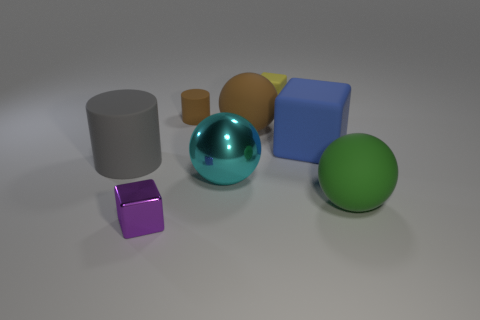Do the matte thing that is in front of the large metallic thing and the small rubber cube have the same color? No, they do not have the same color. The matte object in front of the large metallic sphere is purple, while the small rubber cube is red. Both objects exhibit unique colors and textures, making them distinct from each other. 